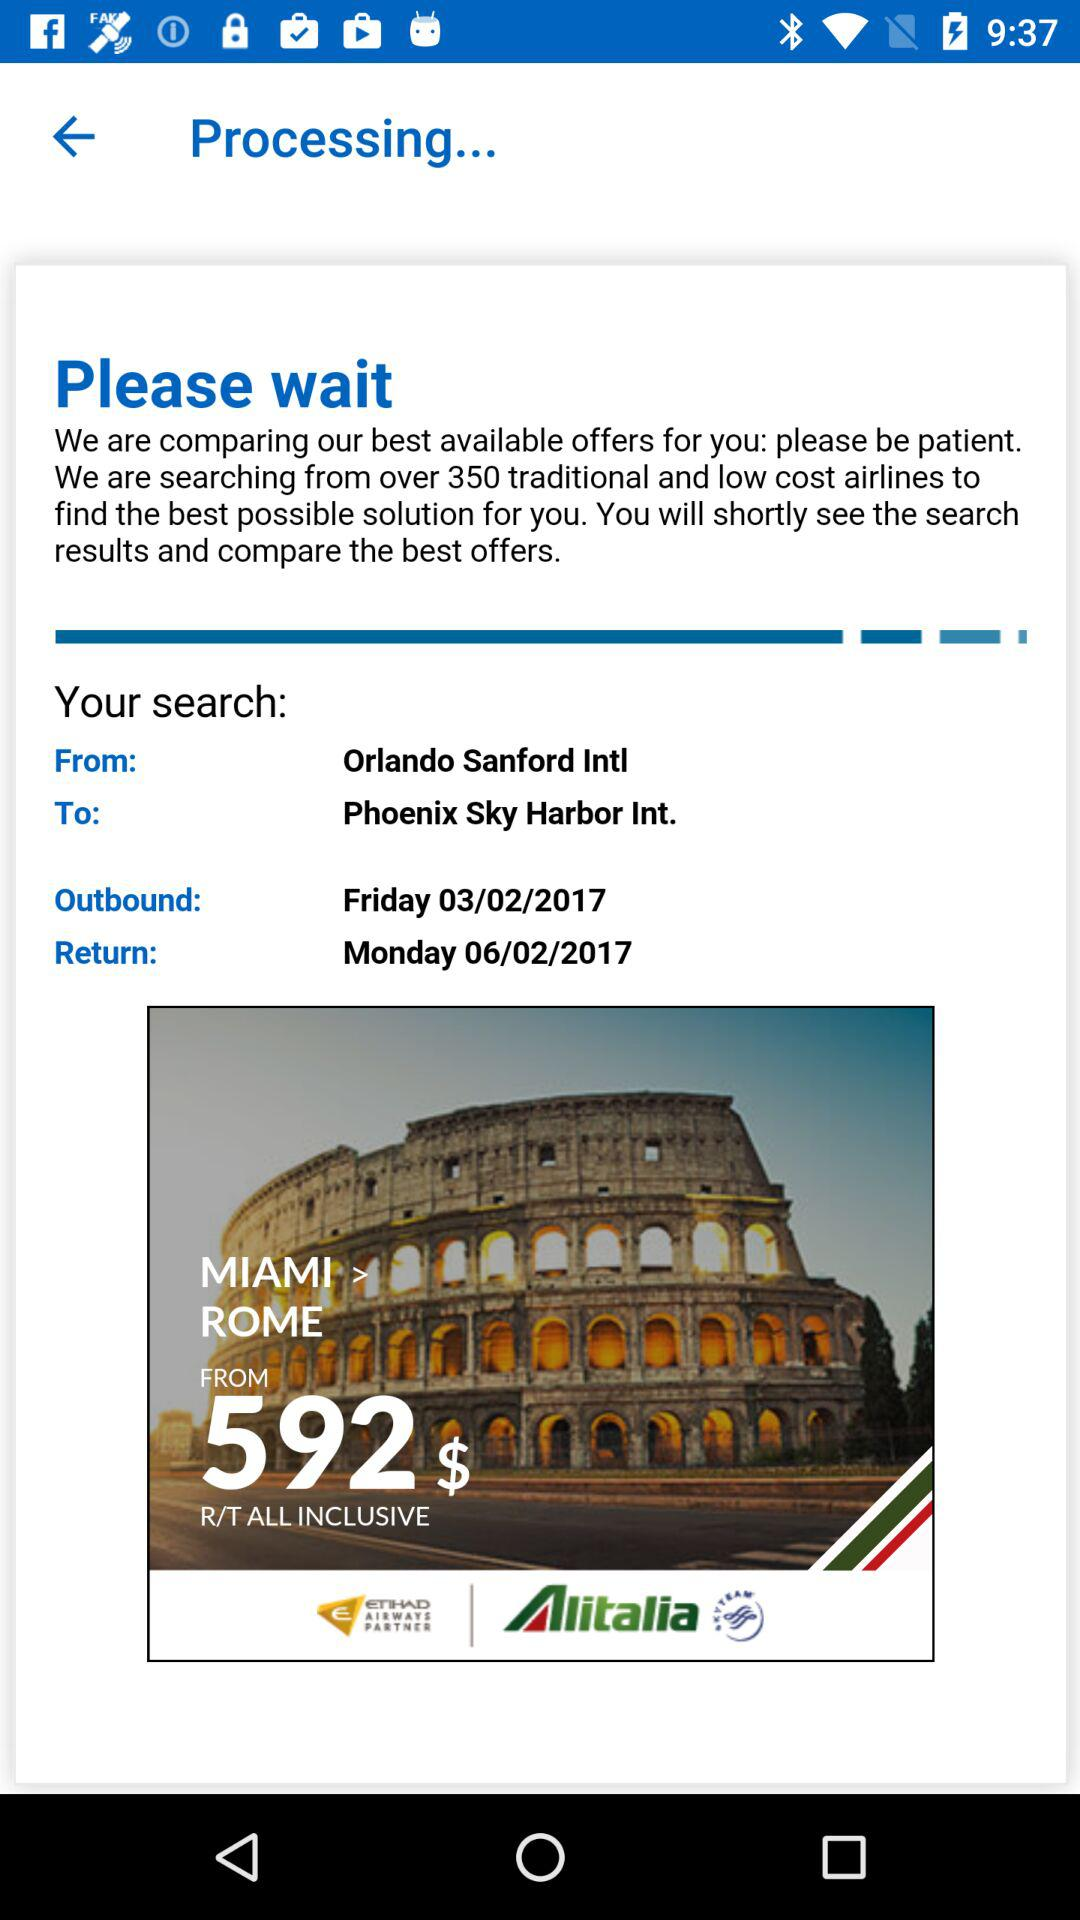Where will the flight depart from? The flight will depart from "Orlando Sanford Intl". 